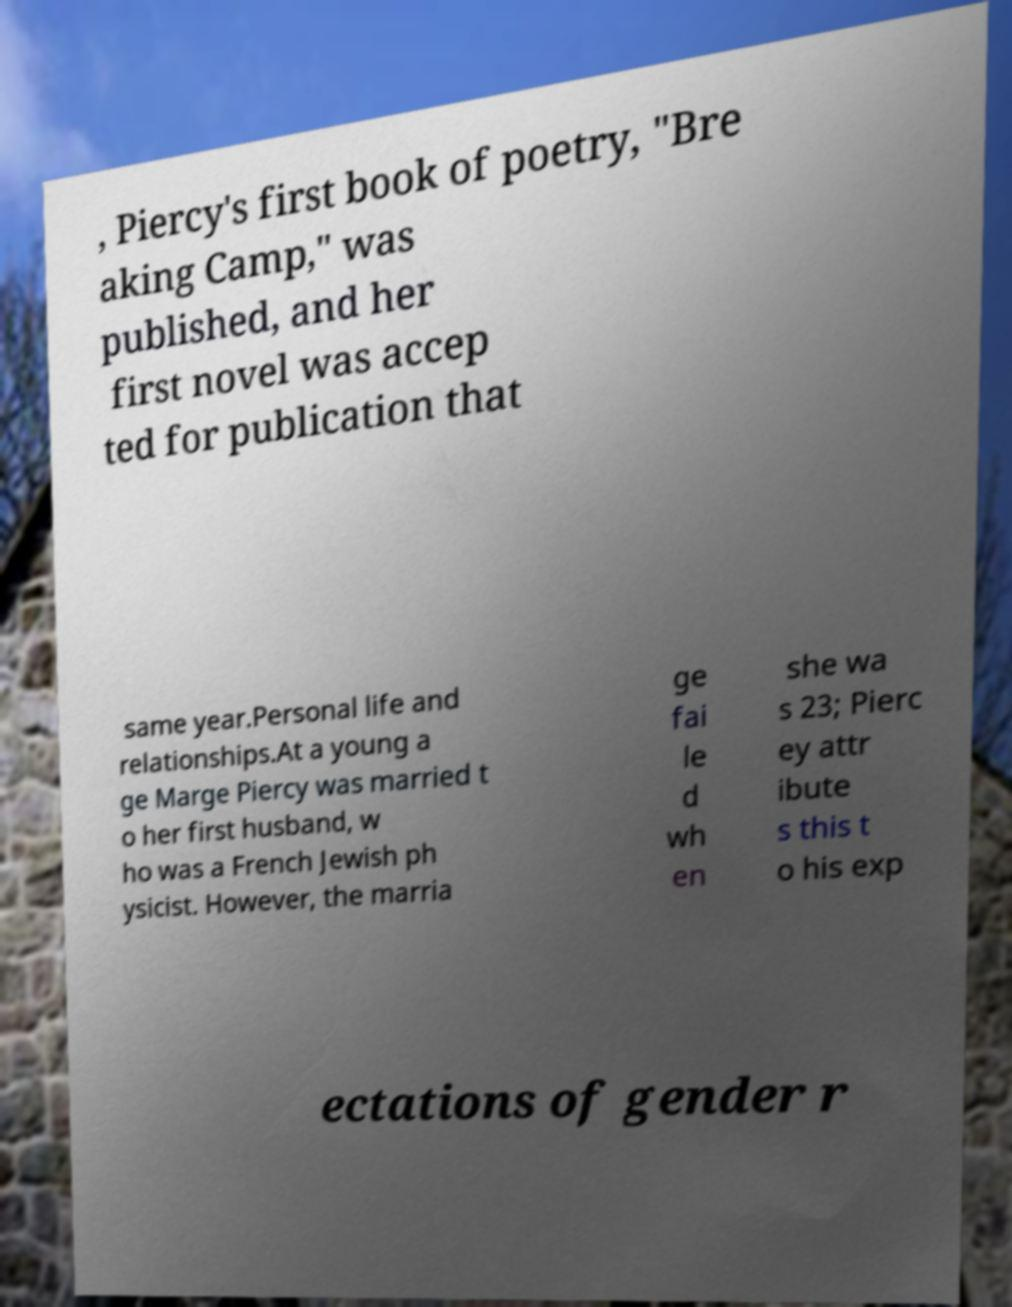Can you read and provide the text displayed in the image?This photo seems to have some interesting text. Can you extract and type it out for me? , Piercy's first book of poetry, "Bre aking Camp," was published, and her first novel was accep ted for publication that same year.Personal life and relationships.At a young a ge Marge Piercy was married t o her first husband, w ho was a French Jewish ph ysicist. However, the marria ge fai le d wh en she wa s 23; Pierc ey attr ibute s this t o his exp ectations of gender r 